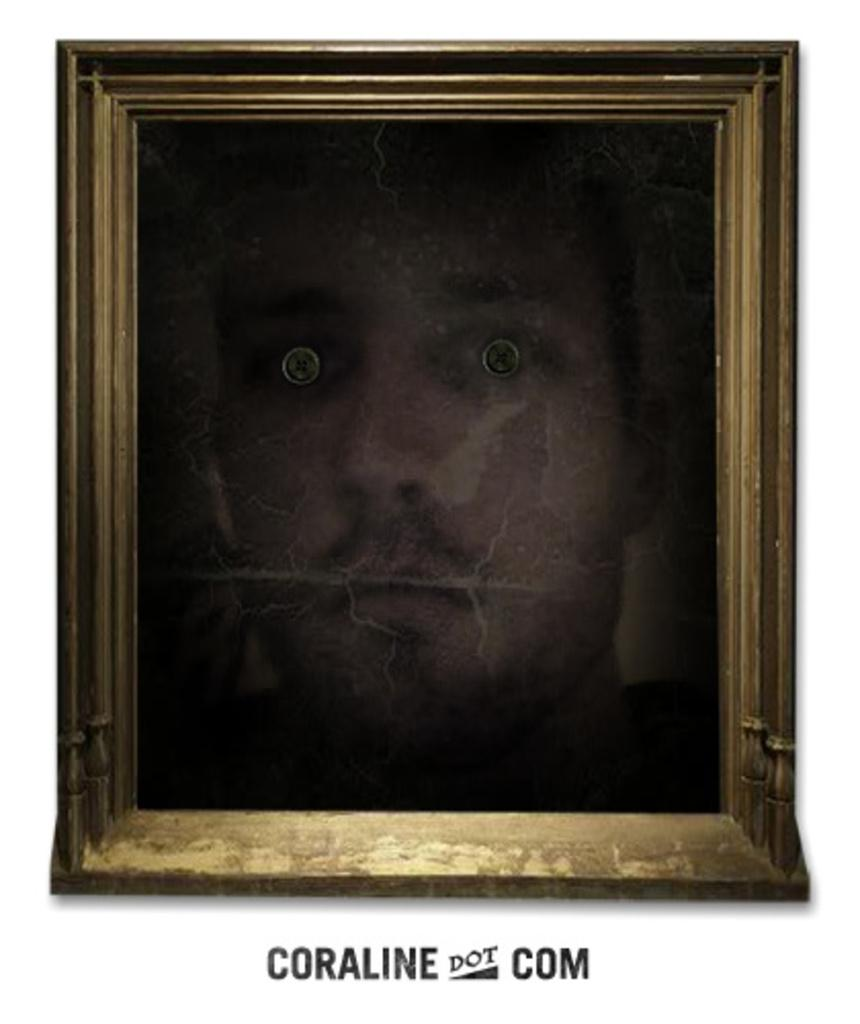<image>
Offer a succinct explanation of the picture presented. framed picture of face with staring eyes and beneath frame is coraline dot com 